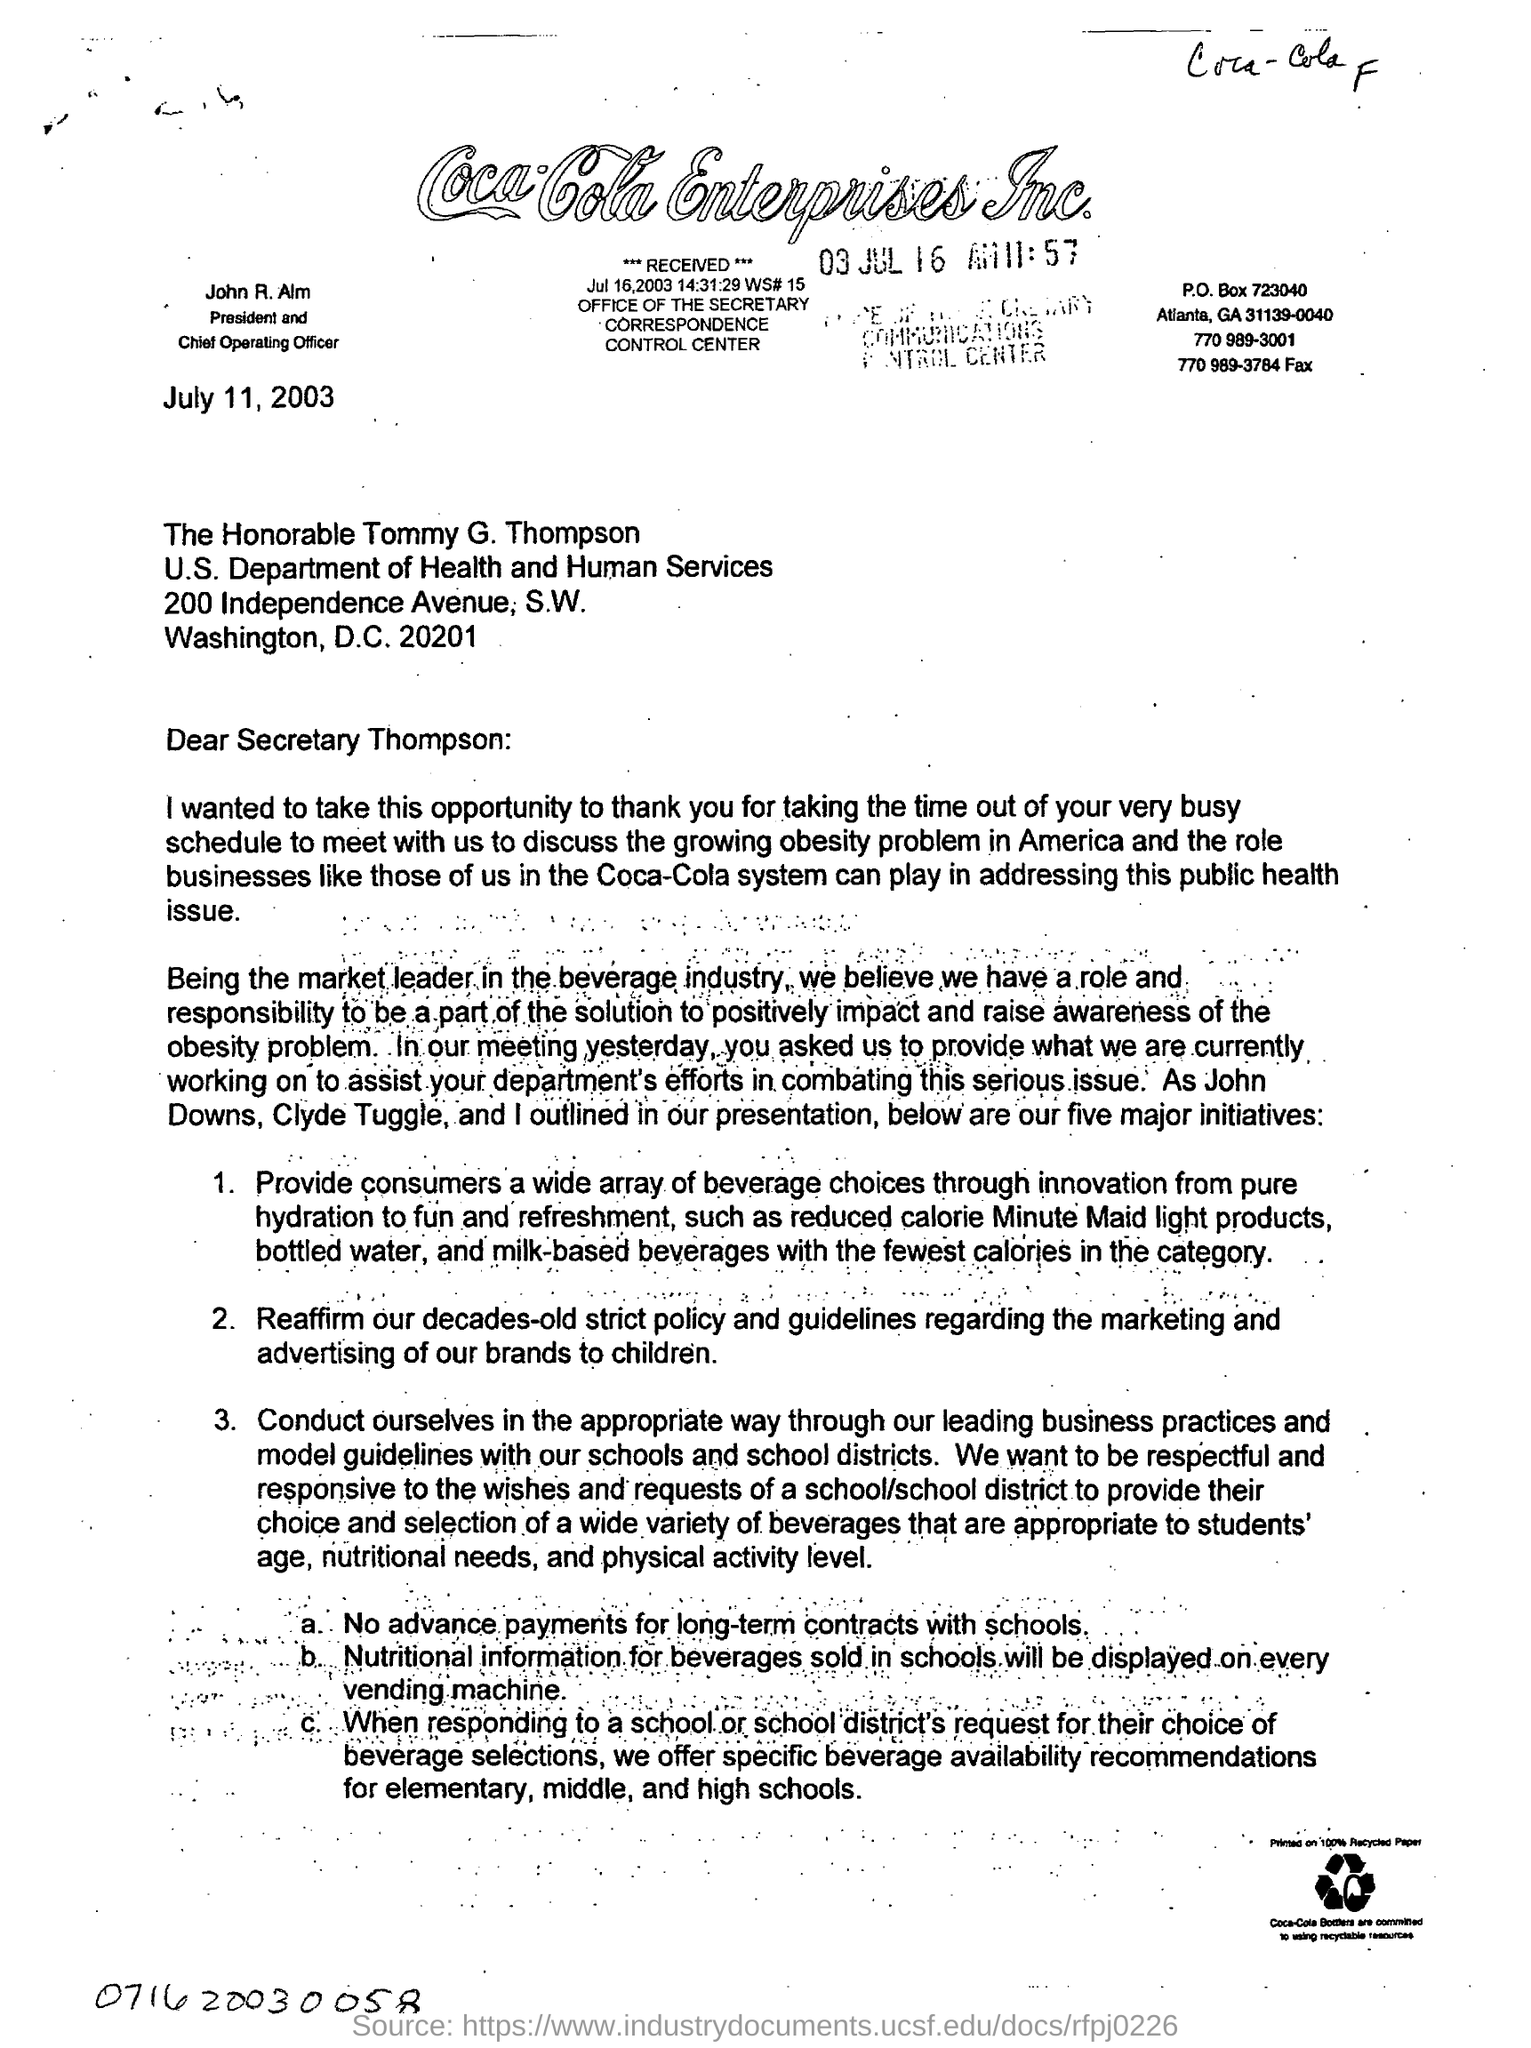Who is the president and chief operating officer?
Your answer should be compact. John R. Alm. What is the 2nd point inthe letter ?
Keep it short and to the point. Reaffirm our decades-old strict policy and guidelines regarding the marketing and advertising of our brands to children. 